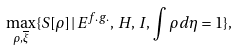<formula> <loc_0><loc_0><loc_500><loc_500>\max _ { \rho , \overline { \xi } } \{ S [ \rho ] \, | \, E ^ { f . g . } , \, H , \, I , \, \int \rho d \eta = 1 \} ,</formula> 